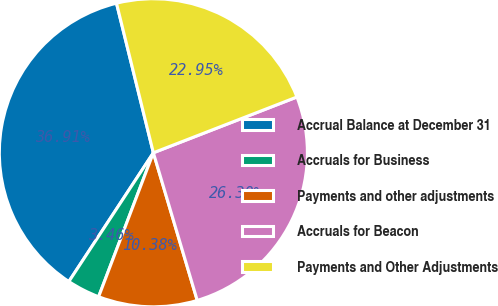Convert chart. <chart><loc_0><loc_0><loc_500><loc_500><pie_chart><fcel>Accrual Balance at December 31<fcel>Accruals for Business<fcel>Payments and other adjustments<fcel>Accruals for Beacon<fcel>Payments and Other Adjustments<nl><fcel>36.91%<fcel>3.46%<fcel>10.38%<fcel>26.3%<fcel>22.95%<nl></chart> 